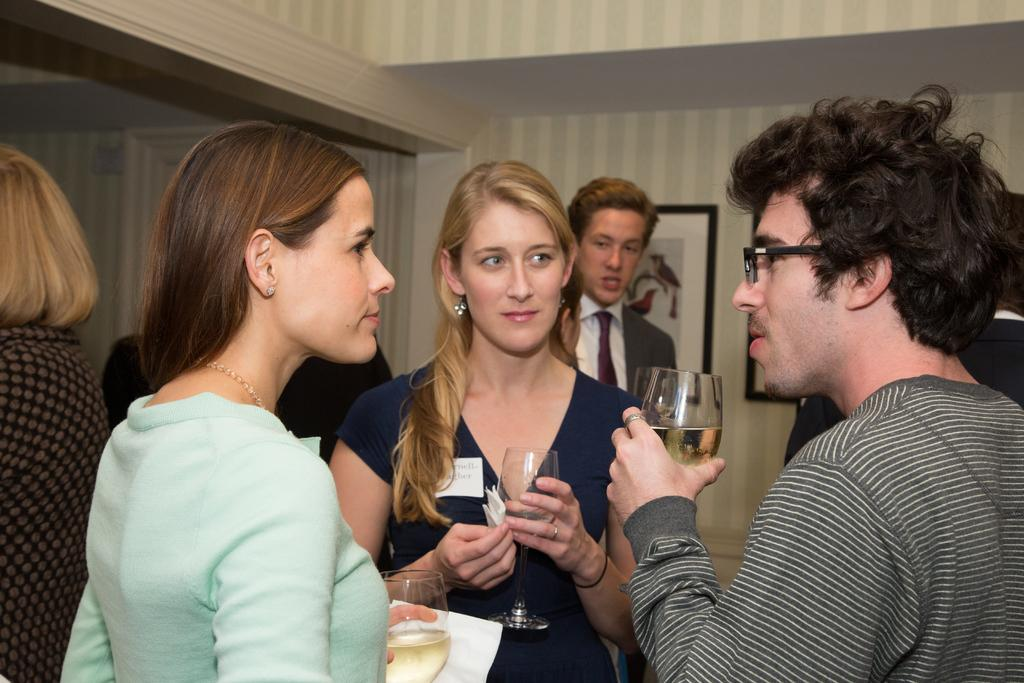How many people are present in the image? There are persons standing in the image. What are some of the persons holding in their hands? Some of the persons are holding glasses and some are holding tissues. What can be seen on the wall in the background of the image? There are photo frames on the wall in the background of the image. What type of expansion is taking place in the image? There is no expansion visible in the image; it is a static image. What channel can be seen on the television in the image? There is no television present in the image. 